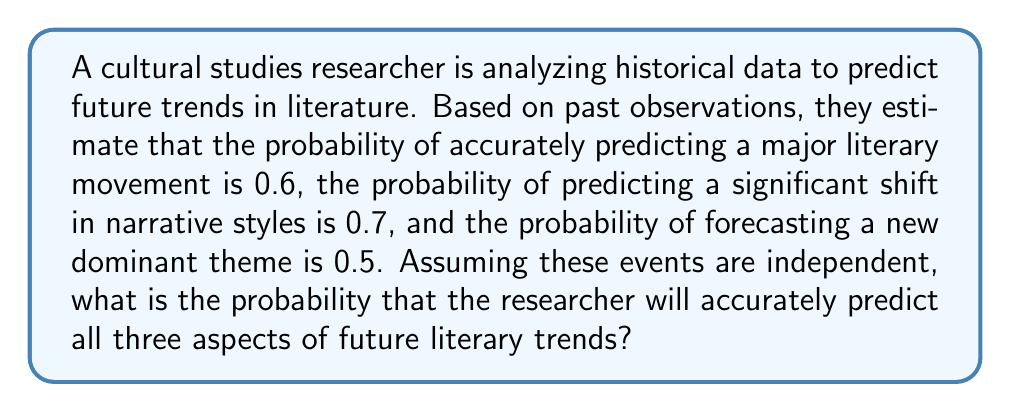Give your solution to this math problem. To solve this problem, we need to apply the multiplication rule for independent events. Since the question states that the events are independent, we can multiply the individual probabilities to find the probability of all events occurring together.

Let's define our events:
A: Accurately predicting a major literary movement (P(A) = 0.6)
B: Predicting a significant shift in narrative styles (P(B) = 0.7)
C: Forecasting a new dominant theme (P(C) = 0.5)

We want to find P(A ∩ B ∩ C), the probability of all three events occurring.

For independent events, the probability of all events occurring is the product of their individual probabilities:

P(A ∩ B ∩ C) = P(A) × P(B) × P(C)

Substituting the given probabilities:

P(A ∩ B ∩ C) = 0.6 × 0.7 × 0.5

Calculating:
P(A ∩ B ∩ C) = 0.21

Therefore, the probability of accurately predicting all three aspects of future literary trends is 0.21 or 21%.
Answer: 0.21 